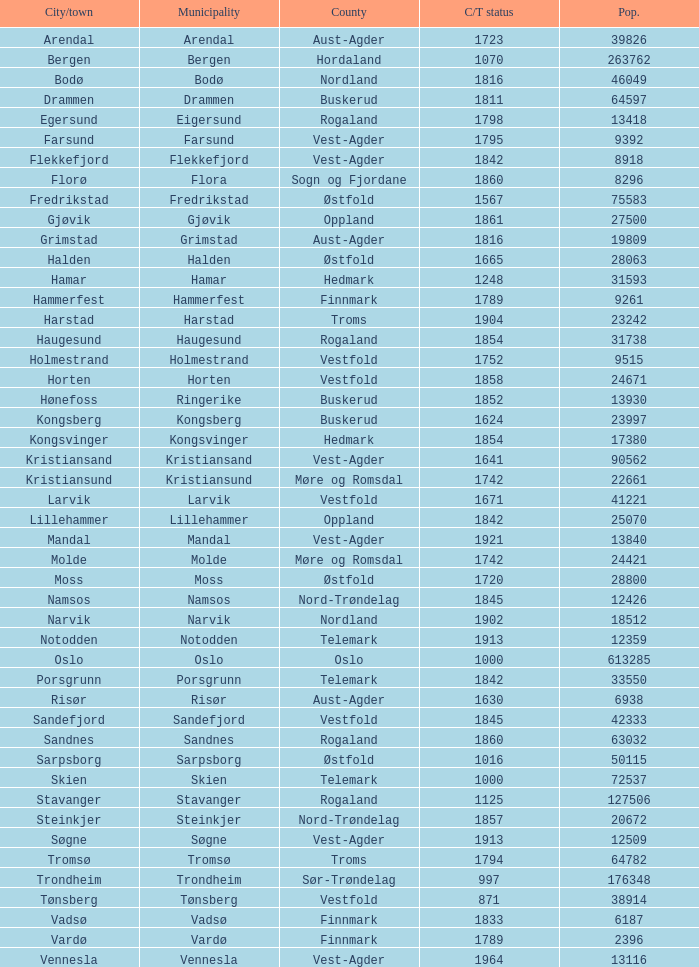What are the cities/towns located in the municipality of Moss? Moss. 